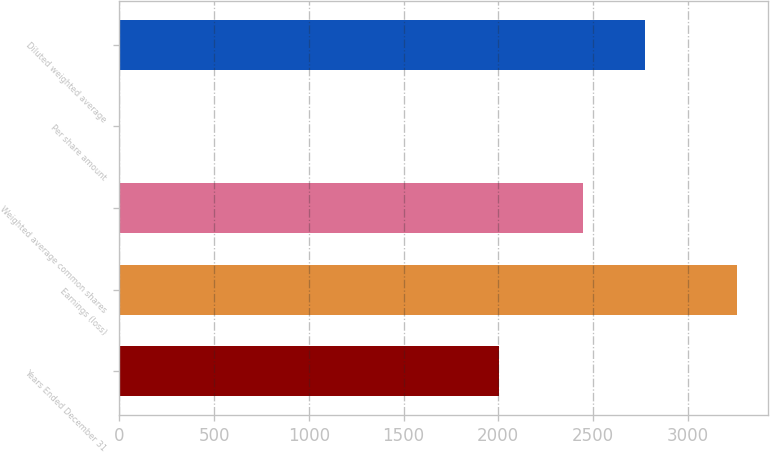Convert chart. <chart><loc_0><loc_0><loc_500><loc_500><bar_chart><fcel>Years Ended December 31<fcel>Earnings (loss)<fcel>Weighted average common shares<fcel>Per share amount<fcel>Diluted weighted average<nl><fcel>2006<fcel>3261<fcel>2446.3<fcel>1.33<fcel>2772.27<nl></chart> 